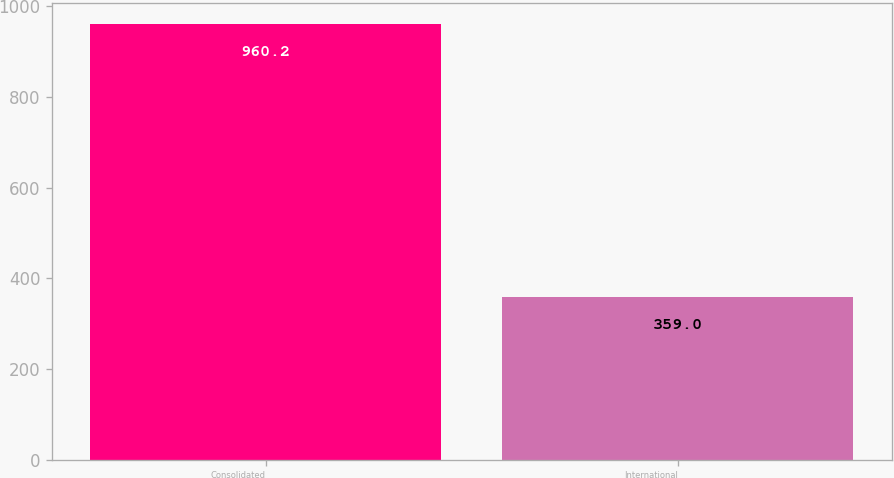<chart> <loc_0><loc_0><loc_500><loc_500><bar_chart><fcel>Consolidated<fcel>International<nl><fcel>960.2<fcel>359<nl></chart> 